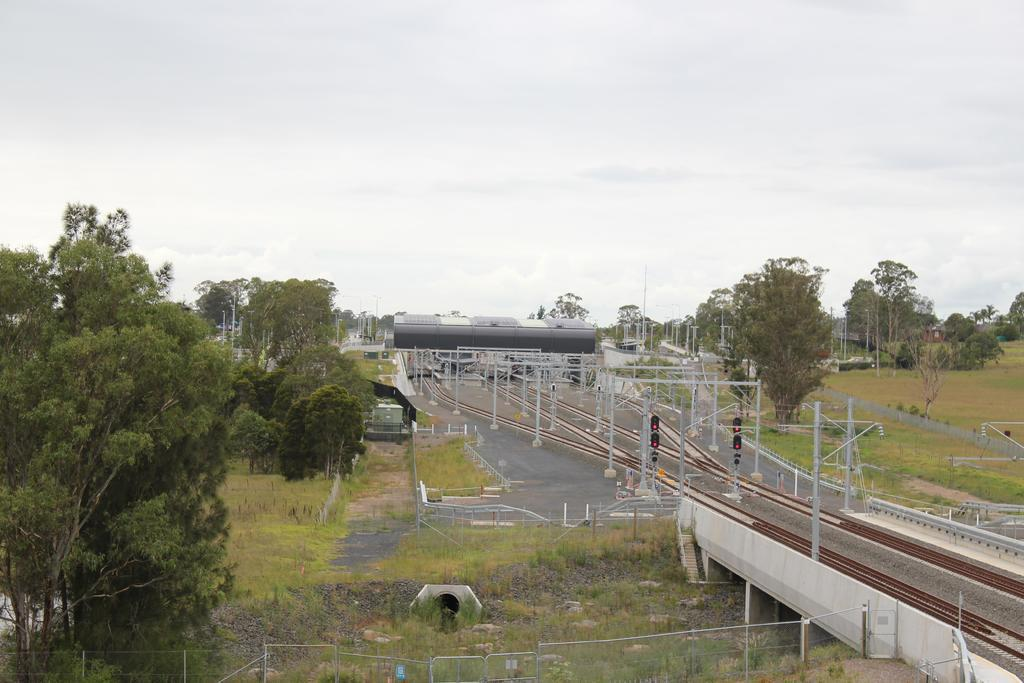What type of vegetation can be seen in the image? There are trees and grass in the image. What structures are present in the image? There are poles, railway tracks, traffic signals, and a bridge in the image. What is visible in the background of the image? The sky is visible in the background of the image. Can you tell me how many babies are playing with the bear in the image? There are no babies or bears present in the image. What type of test is being conducted on the railway tracks in the image? There is no test being conducted on the railway tracks in the image. 